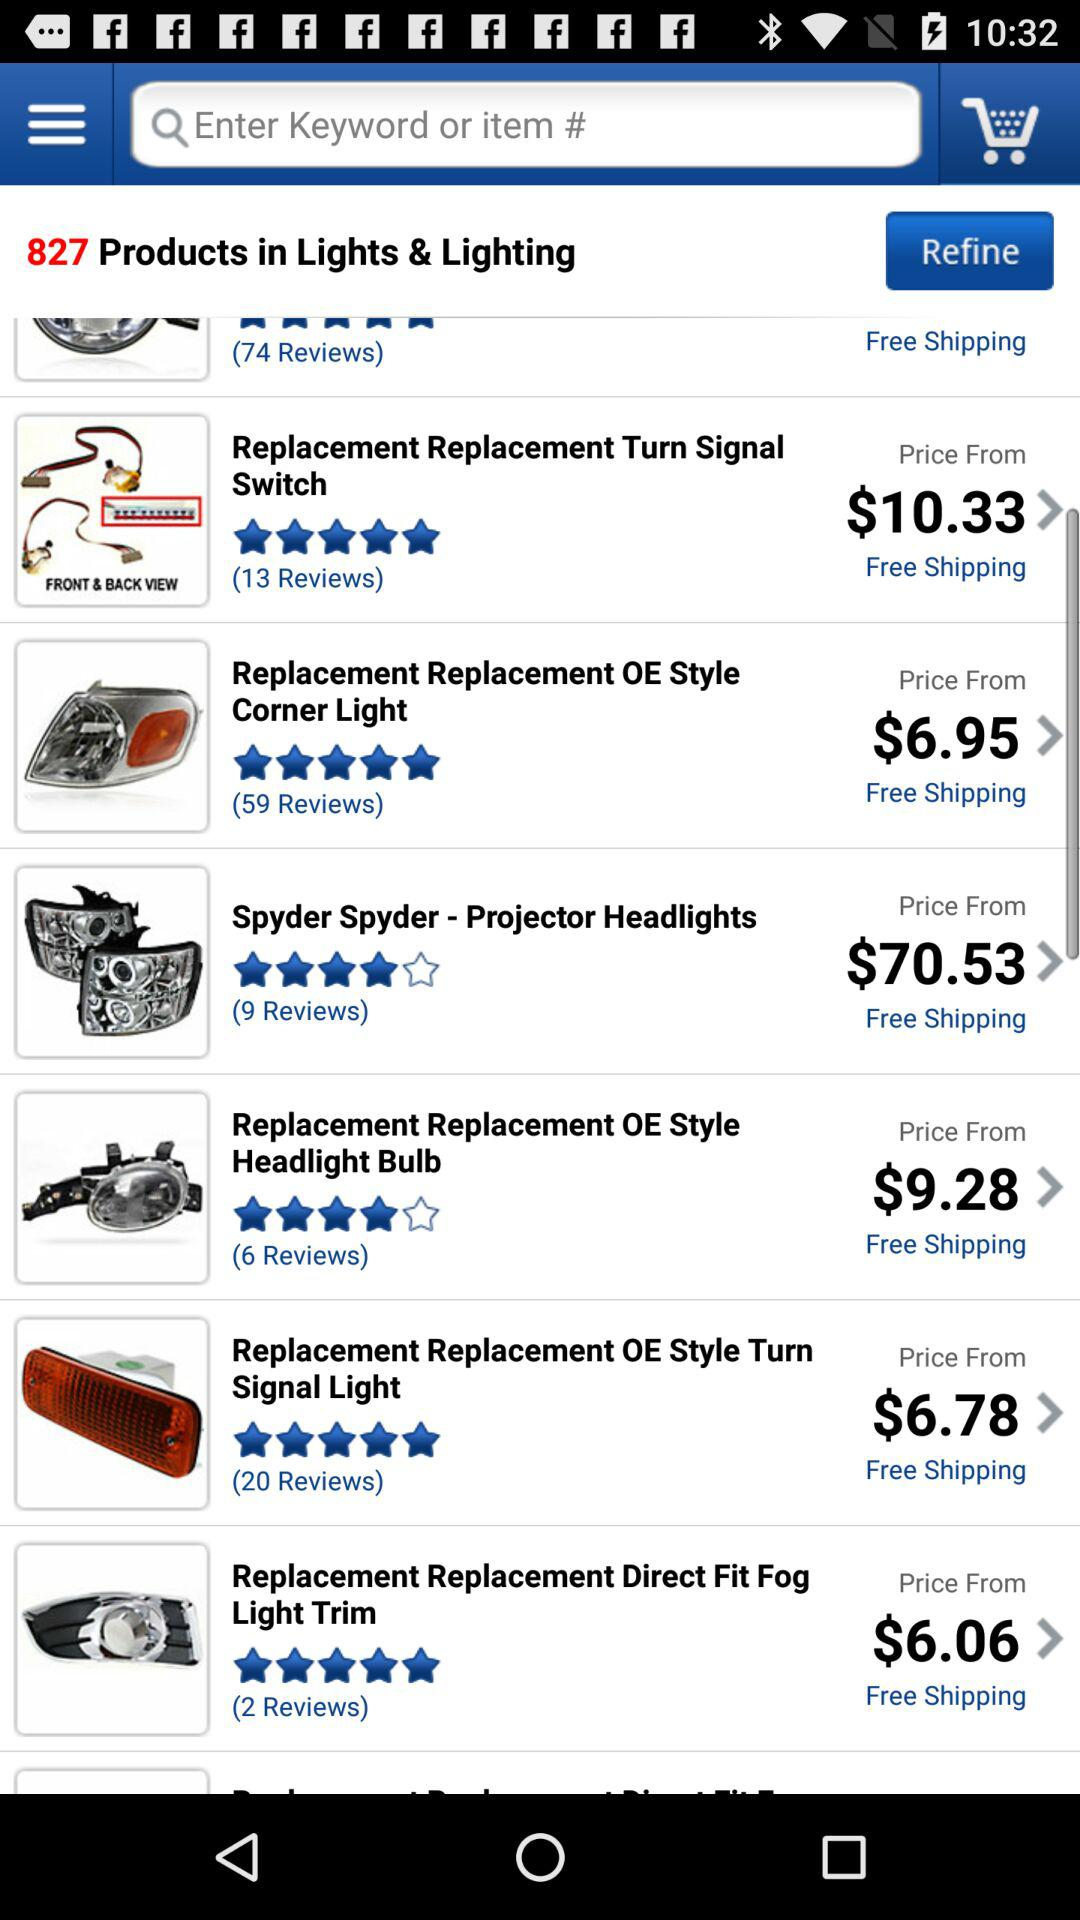What is the price of "Spyder Spyder"? The price of "Spyder Spyder" is $70.53. 